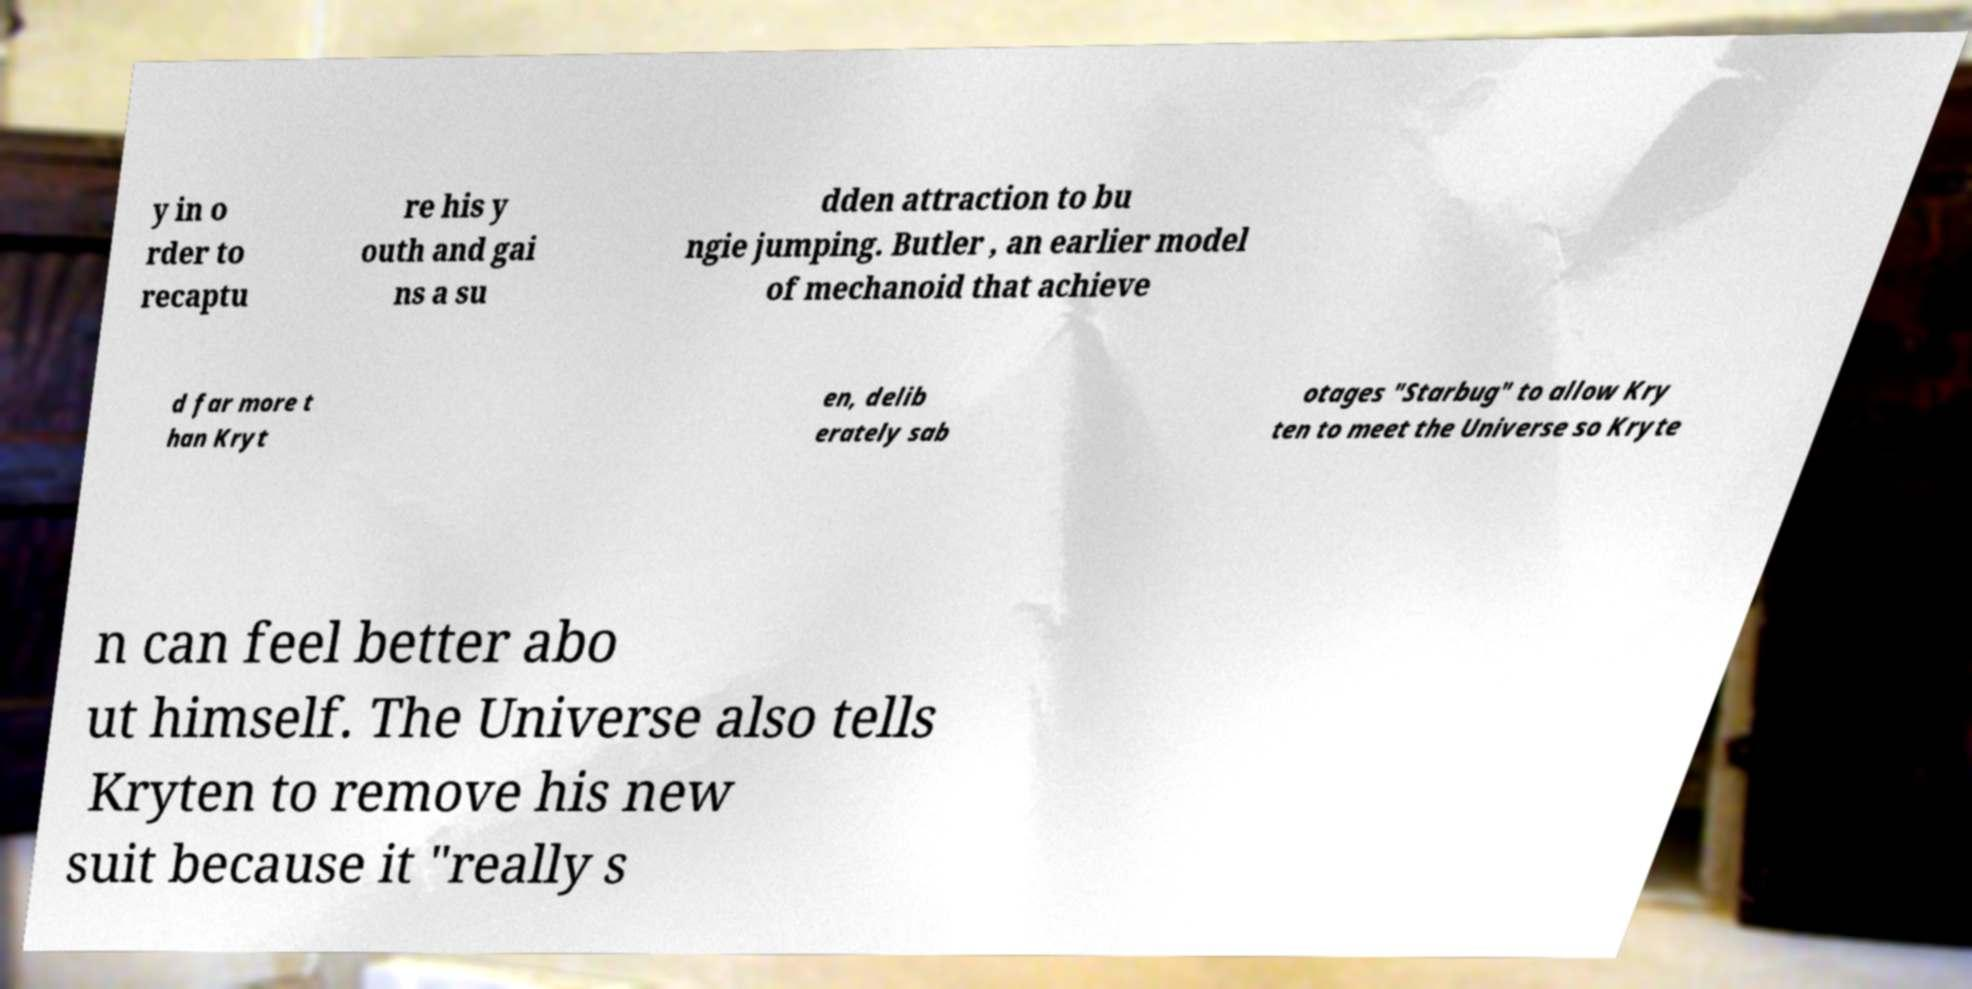Please identify and transcribe the text found in this image. y in o rder to recaptu re his y outh and gai ns a su dden attraction to bu ngie jumping. Butler , an earlier model of mechanoid that achieve d far more t han Kryt en, delib erately sab otages "Starbug" to allow Kry ten to meet the Universe so Kryte n can feel better abo ut himself. The Universe also tells Kryten to remove his new suit because it "really s 